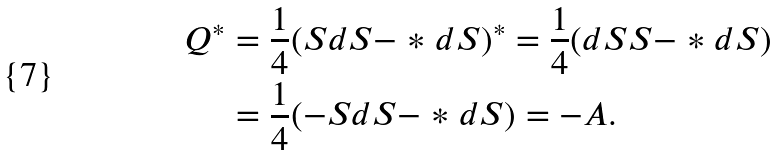<formula> <loc_0><loc_0><loc_500><loc_500>Q ^ { * } & = \frac { 1 } { 4 } ( S d S - * d S ) ^ { * } = \frac { 1 } { 4 } ( d S S - * d S ) \\ & = \frac { 1 } { 4 } ( - S d S - * d S ) = - A .</formula> 